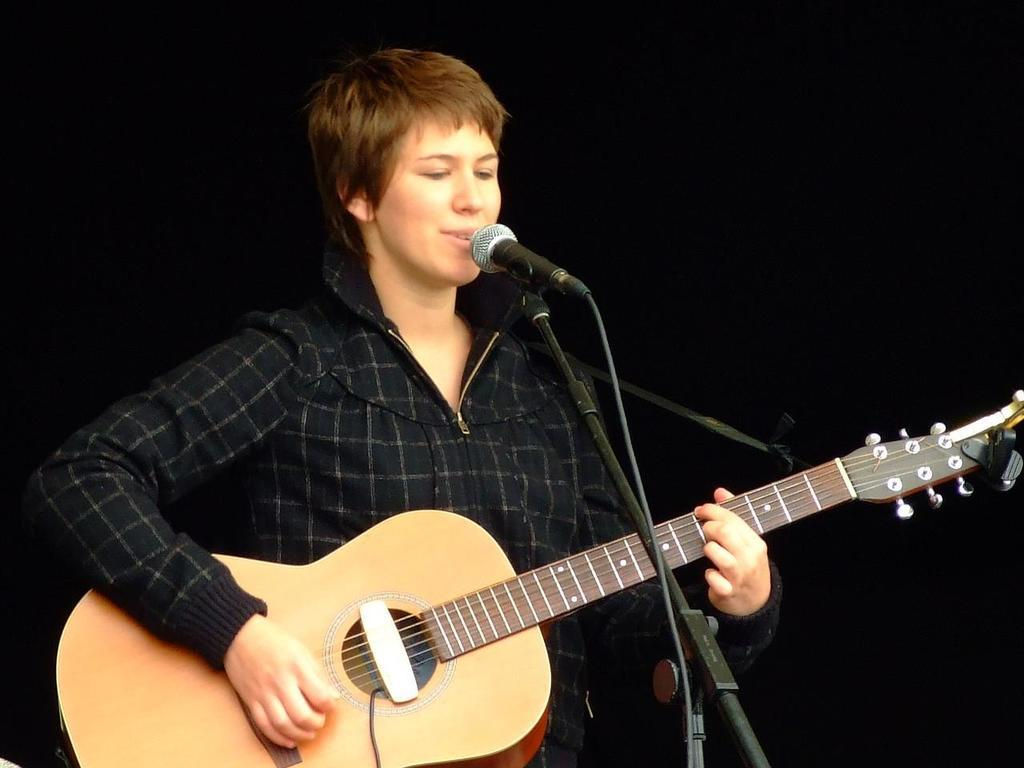Who is the main subject in the image? There is a woman in the image. What is the woman doing in the image? The woman is singing and playing a guitar. What object is the woman holding in the image? The woman is holding a microphone in the image. What type of sack can be seen in the background of the image? There is no sack present in the image. 